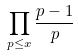<formula> <loc_0><loc_0><loc_500><loc_500>\prod _ { p \leq x } \frac { p - 1 } { p }</formula> 